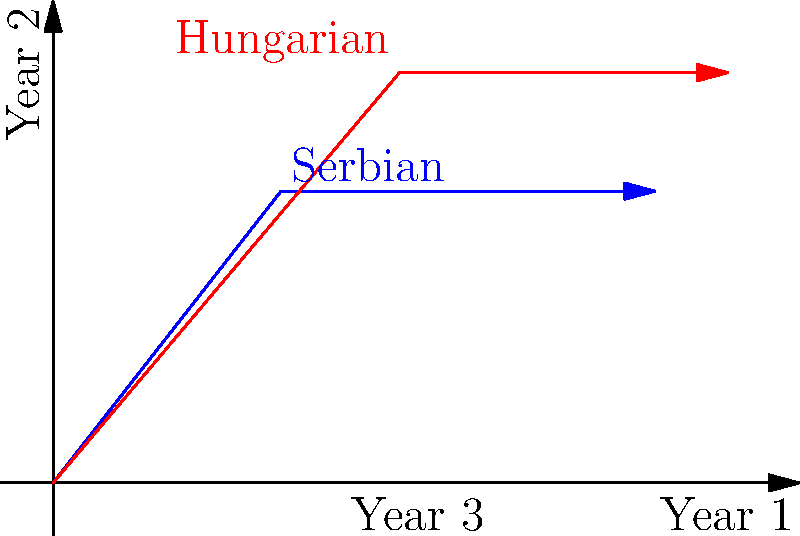The graph shows economic growth vectors for Serbian (blue) and Hungarian (red) communities over three years. Each vector component represents the growth rate for a year. Given that the magnitude of a vector $\vec{v} = (x, y, z)$ is calculated as $\|\vec{v}\| = \sqrt{x^2 + y^2 + z^2}$, determine which community experienced higher overall economic growth and by what percentage? Let's approach this step-by-step:

1) First, we need to identify the growth rates for each community:
   Serbian: $\vec{s} = (2.5, 3.2, 4.1)$
   Hungarian: $\vec{h} = (3.8, 4.5, 3.6)$

2) Now, let's calculate the magnitude of each vector:

   For Serbian:
   $\|\vec{s}\| = \sqrt{2.5^2 + 3.2^2 + 4.1^2}$
   $= \sqrt{6.25 + 10.24 + 16.81}$
   $= \sqrt{33.3}$
   $\approx 5.77$

   For Hungarian:
   $\|\vec{h}\| = \sqrt{3.8^2 + 4.5^2 + 3.6^2}$
   $= \sqrt{14.44 + 20.25 + 12.96}$
   $= \sqrt{47.65}$
   $\approx 6.90$

3) The Hungarian community has a higher magnitude, indicating higher overall growth.

4) To calculate the percentage difference:
   $\text{Percentage Difference} = \frac{6.90 - 5.77}{5.77} \times 100\% \approx 19.58\%$

Therefore, the Hungarian community experienced approximately 19.58% higher overall economic growth compared to the Serbian community.
Answer: Hungarian community; 19.58% higher 